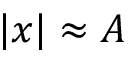<formula> <loc_0><loc_0><loc_500><loc_500>| x | \approx A</formula> 